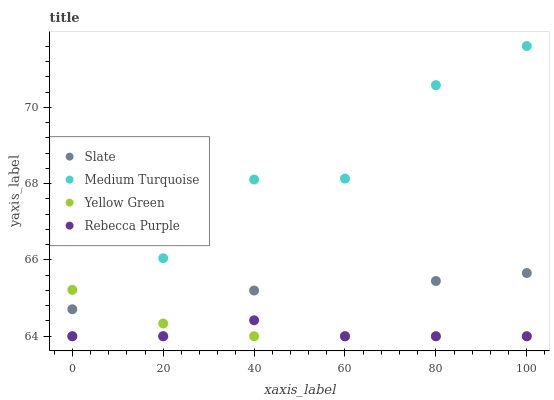Does Rebecca Purple have the minimum area under the curve?
Answer yes or no. Yes. Does Medium Turquoise have the maximum area under the curve?
Answer yes or no. Yes. Does Yellow Green have the minimum area under the curve?
Answer yes or no. No. Does Yellow Green have the maximum area under the curve?
Answer yes or no. No. Is Yellow Green the smoothest?
Answer yes or no. Yes. Is Slate the roughest?
Answer yes or no. Yes. Is Medium Turquoise the smoothest?
Answer yes or no. No. Is Medium Turquoise the roughest?
Answer yes or no. No. Does Slate have the lowest value?
Answer yes or no. Yes. Does Medium Turquoise have the highest value?
Answer yes or no. Yes. Does Yellow Green have the highest value?
Answer yes or no. No. Does Slate intersect Rebecca Purple?
Answer yes or no. Yes. Is Slate less than Rebecca Purple?
Answer yes or no. No. Is Slate greater than Rebecca Purple?
Answer yes or no. No. 